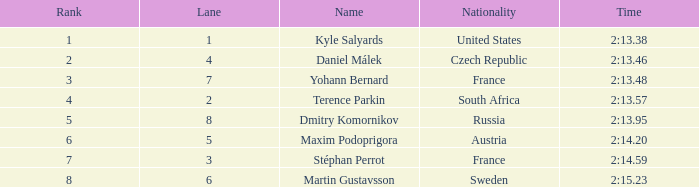What was Stéphan Perrot rank average? 7.0. 